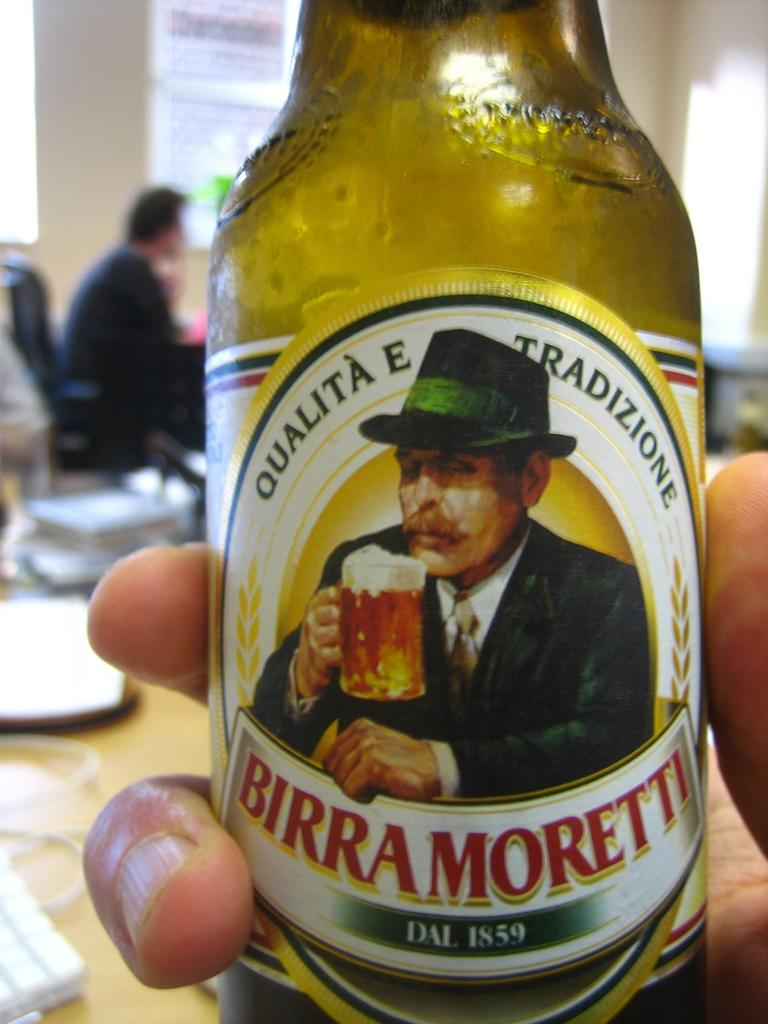What is in the person's hand in the image? There is a cool drink bottle in the person's hand. What can be identified from the writing on the bottle? The words "birra moretti" are written on the bottle. How does the ray twist around the representative in the image? There is no ray or representative present in the image; it only features a cool drink bottle in someone's hand. 